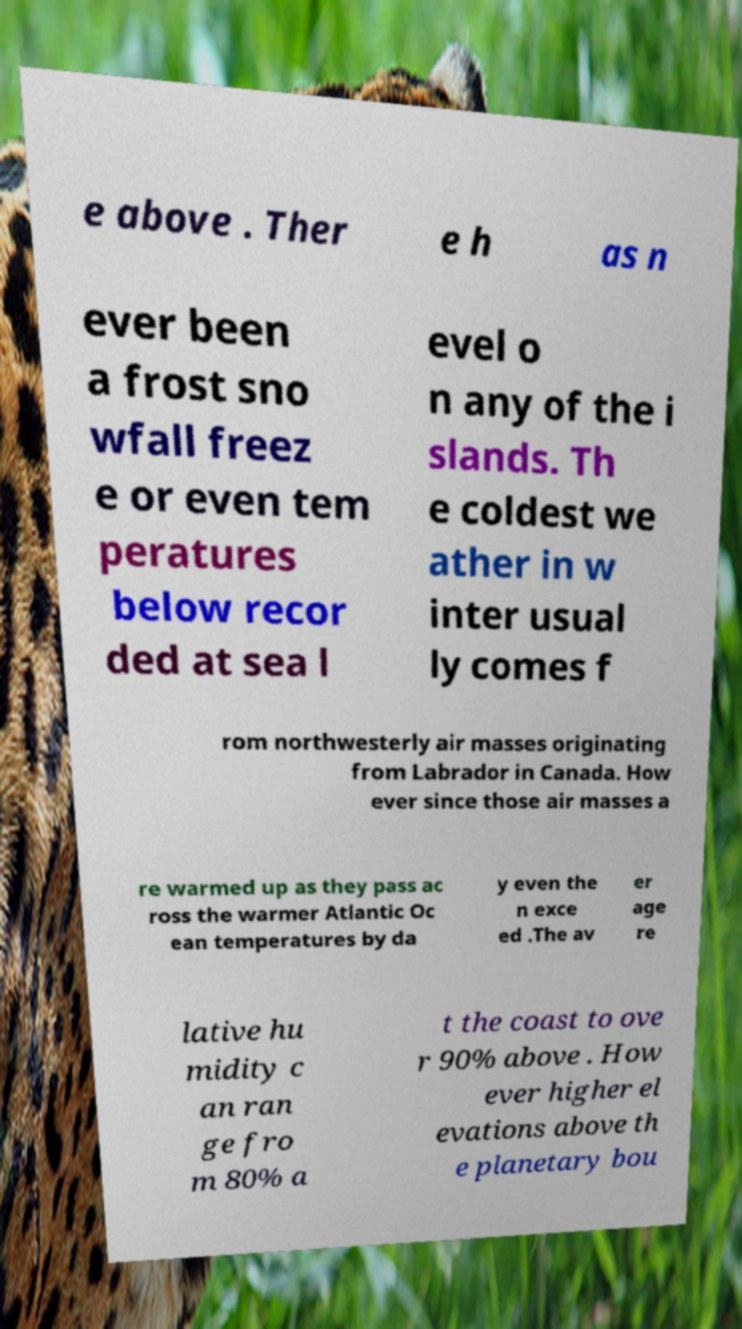What messages or text are displayed in this image? I need them in a readable, typed format. e above . Ther e h as n ever been a frost sno wfall freez e or even tem peratures below recor ded at sea l evel o n any of the i slands. Th e coldest we ather in w inter usual ly comes f rom northwesterly air masses originating from Labrador in Canada. How ever since those air masses a re warmed up as they pass ac ross the warmer Atlantic Oc ean temperatures by da y even the n exce ed .The av er age re lative hu midity c an ran ge fro m 80% a t the coast to ove r 90% above . How ever higher el evations above th e planetary bou 